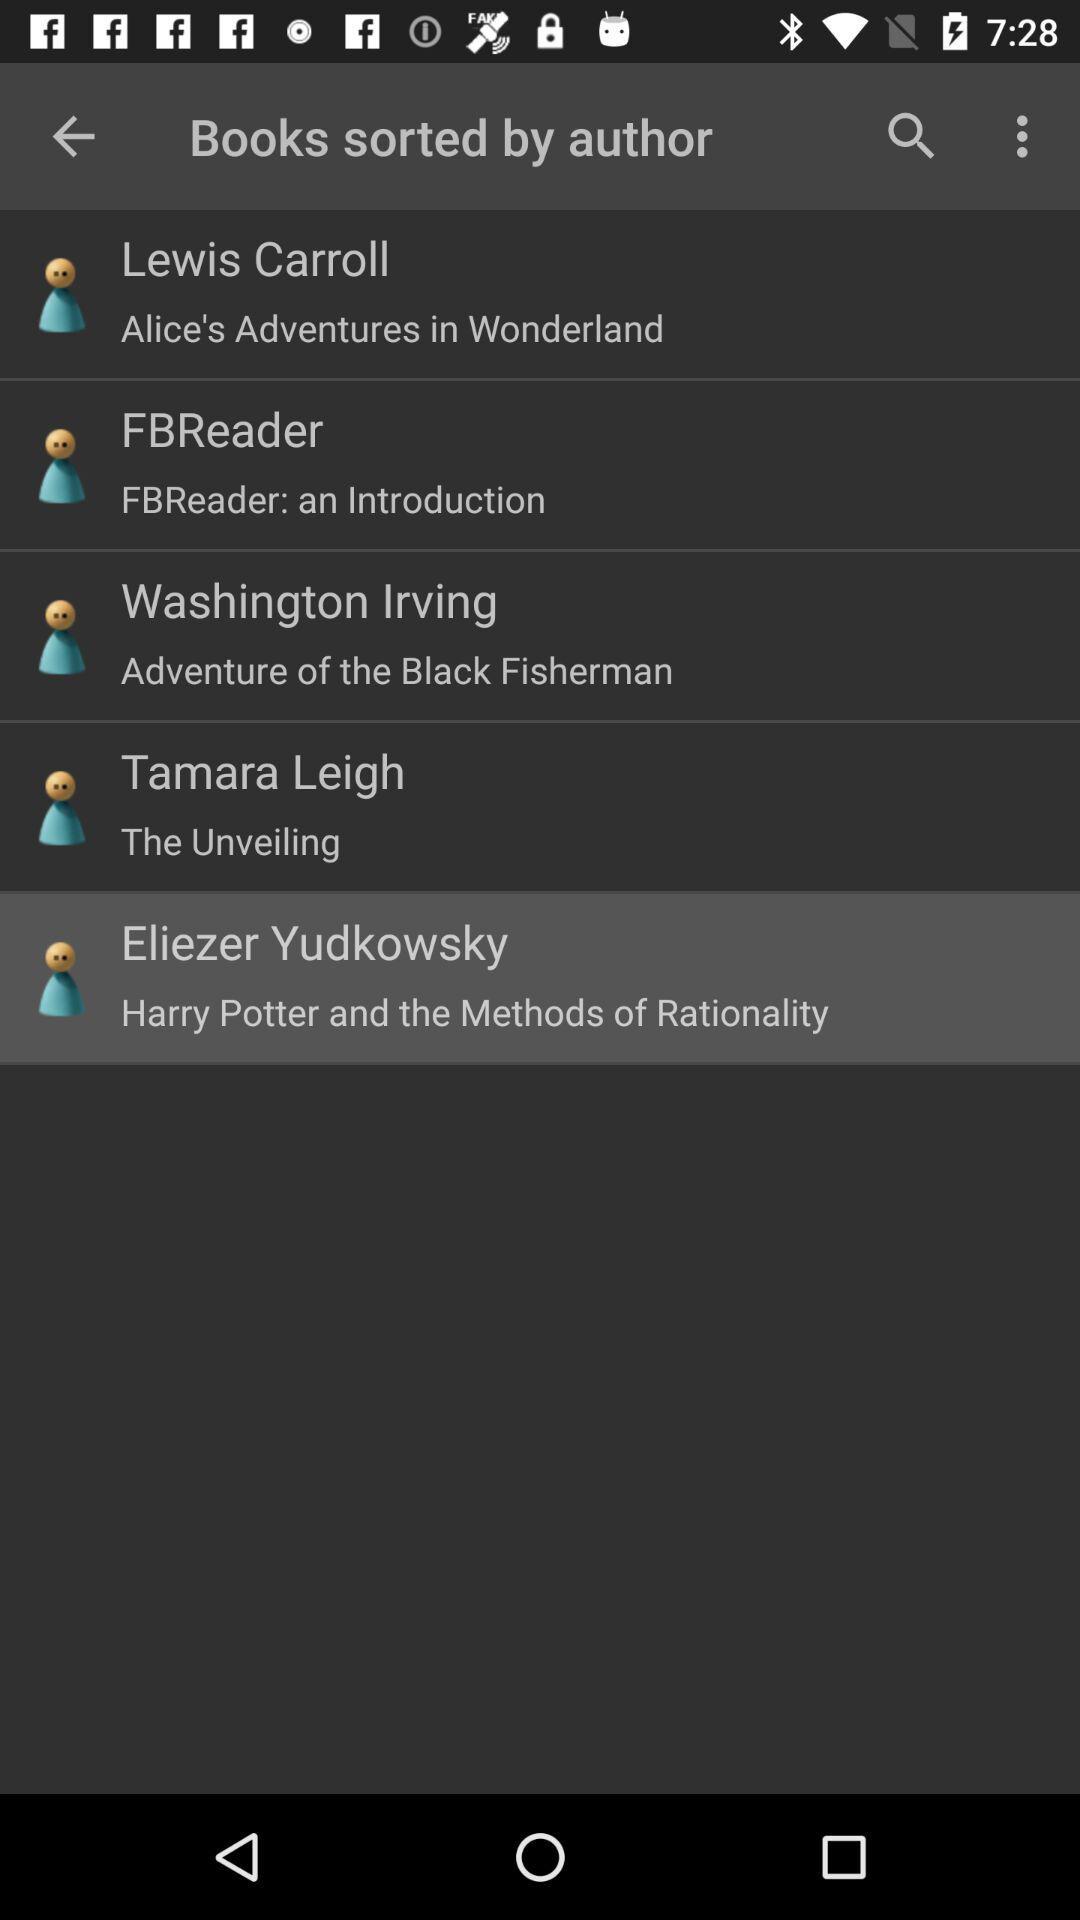Who is the author of "Alice's Adventures in Wonderland"? The author of "Alice's Adventures in Wonderland" is Lewis Carroll. 